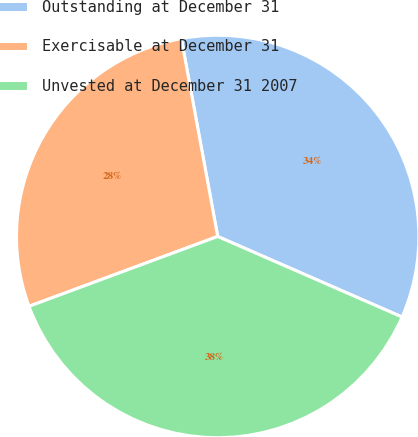Convert chart to OTSL. <chart><loc_0><loc_0><loc_500><loc_500><pie_chart><fcel>Outstanding at December 31<fcel>Exercisable at December 31<fcel>Unvested at December 31 2007<nl><fcel>34.45%<fcel>27.75%<fcel>37.8%<nl></chart> 